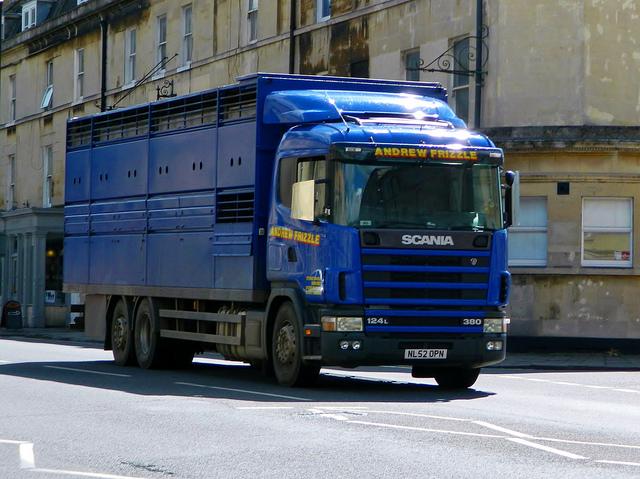Who owns this truck?
Short answer required. Andrew frizzle. What is the truck used for?
Be succinct. Sanitation. What is the truck's license plate number?
Quick response, please. Wi 52 expn. 